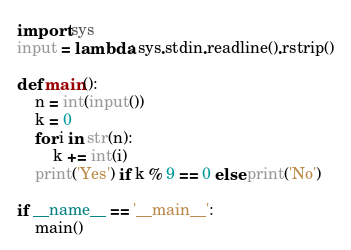<code> <loc_0><loc_0><loc_500><loc_500><_Python_>import sys
input = lambda: sys.stdin.readline().rstrip()

def main():
    n = int(input())
    k = 0
    for i in str(n):
        k += int(i)
    print('Yes') if k % 9 == 0 else print('No')

if __name__ == '__main__':
    main()
</code> 